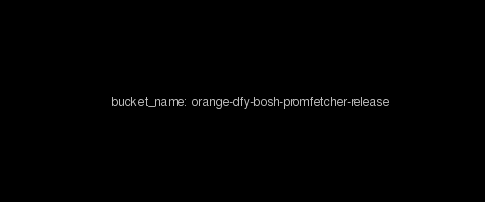<code> <loc_0><loc_0><loc_500><loc_500><_YAML_>    bucket_name: orange-dfy-bosh-promfetcher-release</code> 